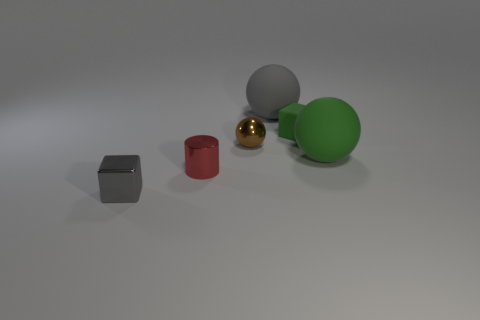Add 3 tiny spheres. How many objects exist? 9 Subtract all blocks. How many objects are left? 4 Subtract all blue matte cylinders. Subtract all big green balls. How many objects are left? 5 Add 2 rubber things. How many rubber things are left? 5 Add 3 yellow spheres. How many yellow spheres exist? 3 Subtract 0 brown cylinders. How many objects are left? 6 